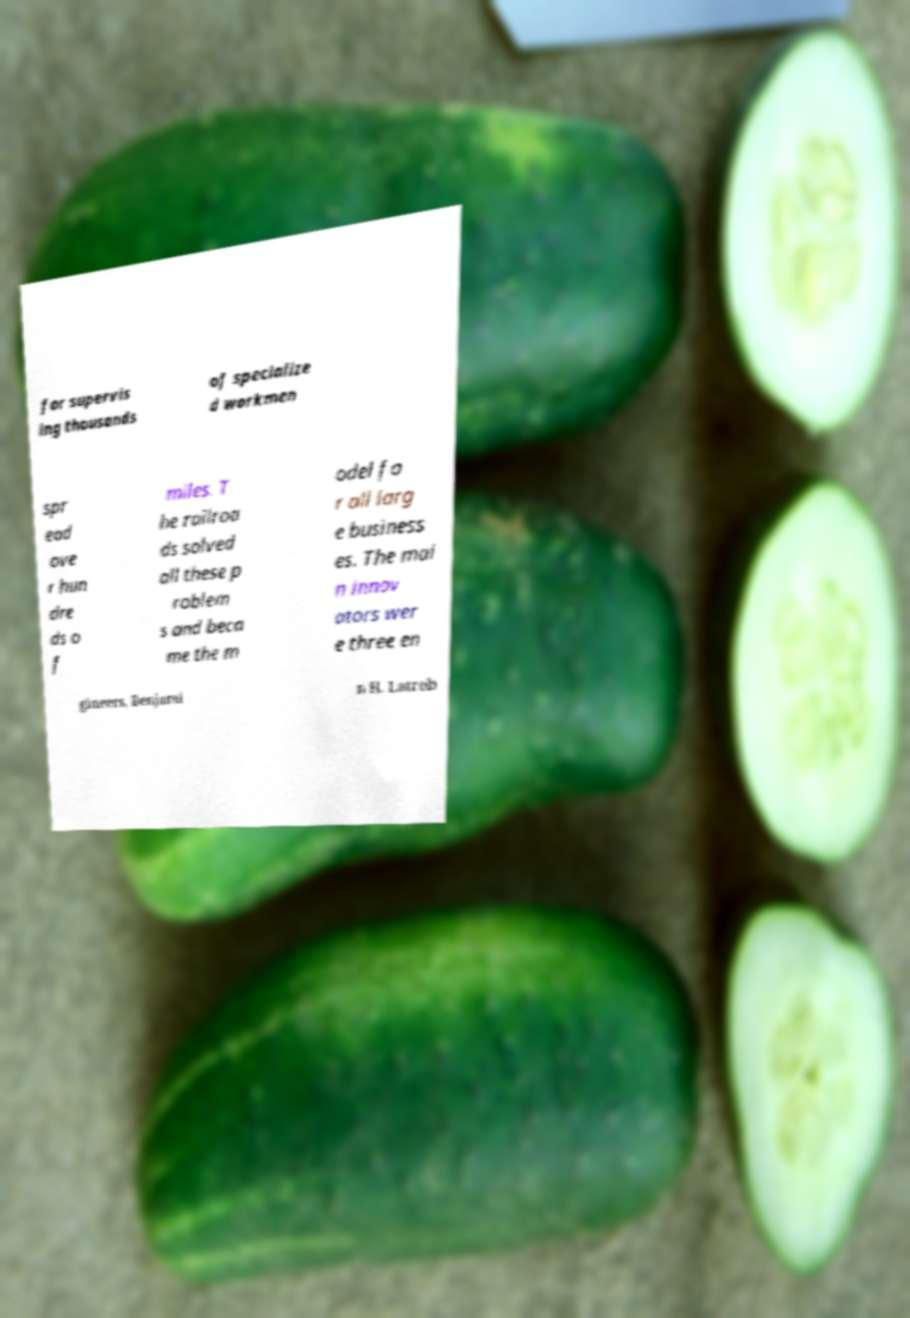Please identify and transcribe the text found in this image. for supervis ing thousands of specialize d workmen spr ead ove r hun dre ds o f miles. T he railroa ds solved all these p roblem s and beca me the m odel fo r all larg e business es. The mai n innov ators wer e three en gineers, Benjami n H. Latrob 